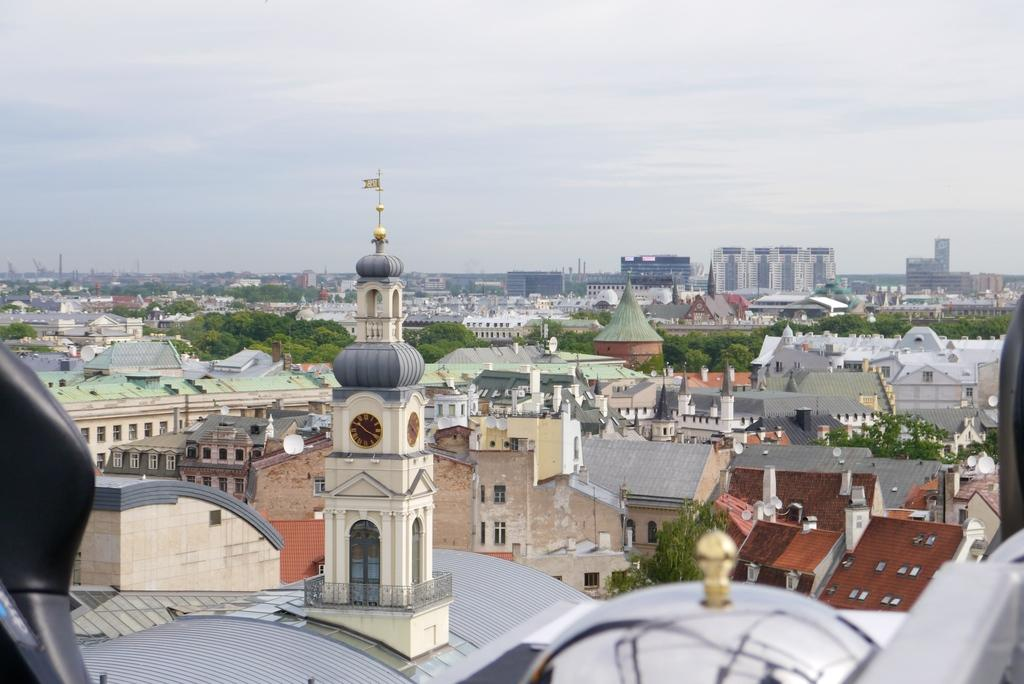What type of structures can be seen in the image? There are buildings in the image. What other natural elements are present in the image? There are trees in the image. What is visible at the top of the image? The sky is visible at the top of the image. How many ants can be seen crawling on the receipt in the image? There is no receipt or ants present in the image. What type of clouds can be seen in the image? The provided facts do not mention any clouds in the image. 